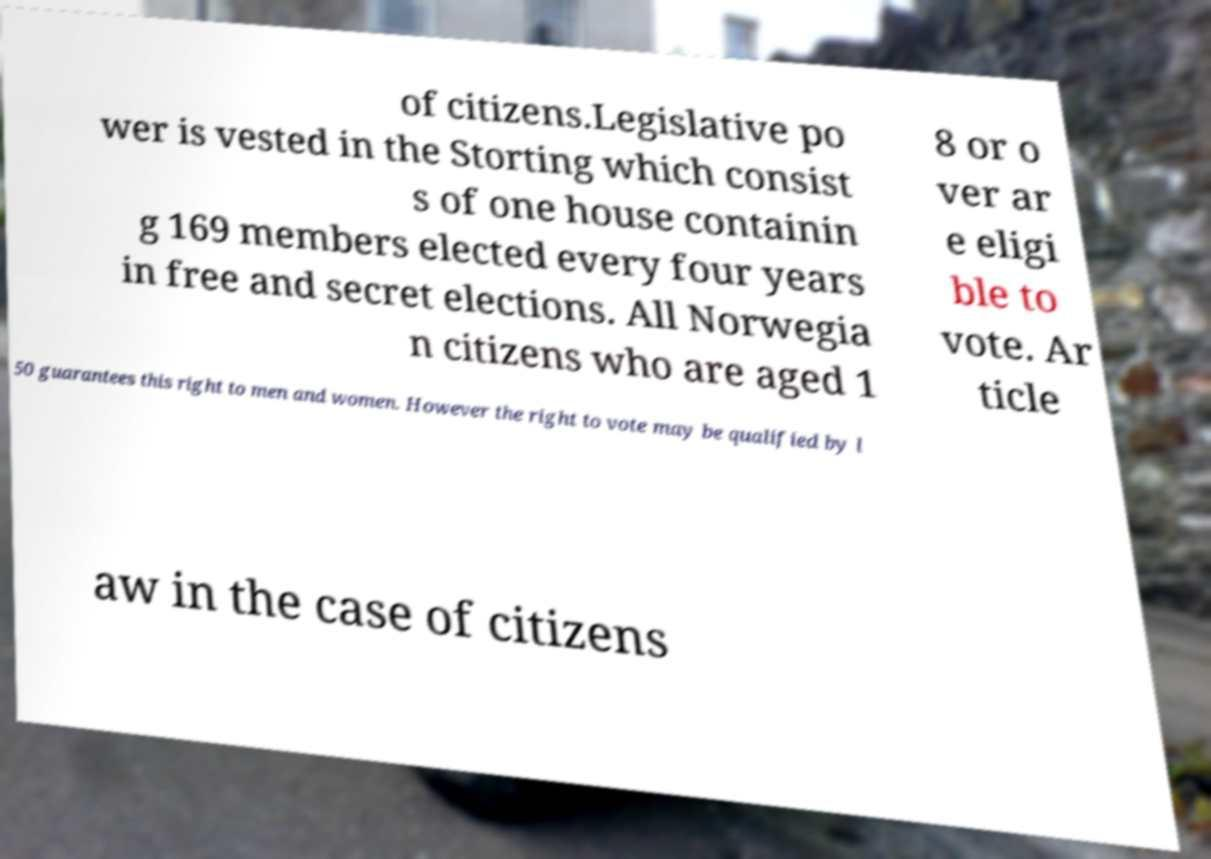Could you extract and type out the text from this image? of citizens.Legislative po wer is vested in the Storting which consist s of one house containin g 169 members elected every four years in free and secret elections. All Norwegia n citizens who are aged 1 8 or o ver ar e eligi ble to vote. Ar ticle 50 guarantees this right to men and women. However the right to vote may be qualified by l aw in the case of citizens 